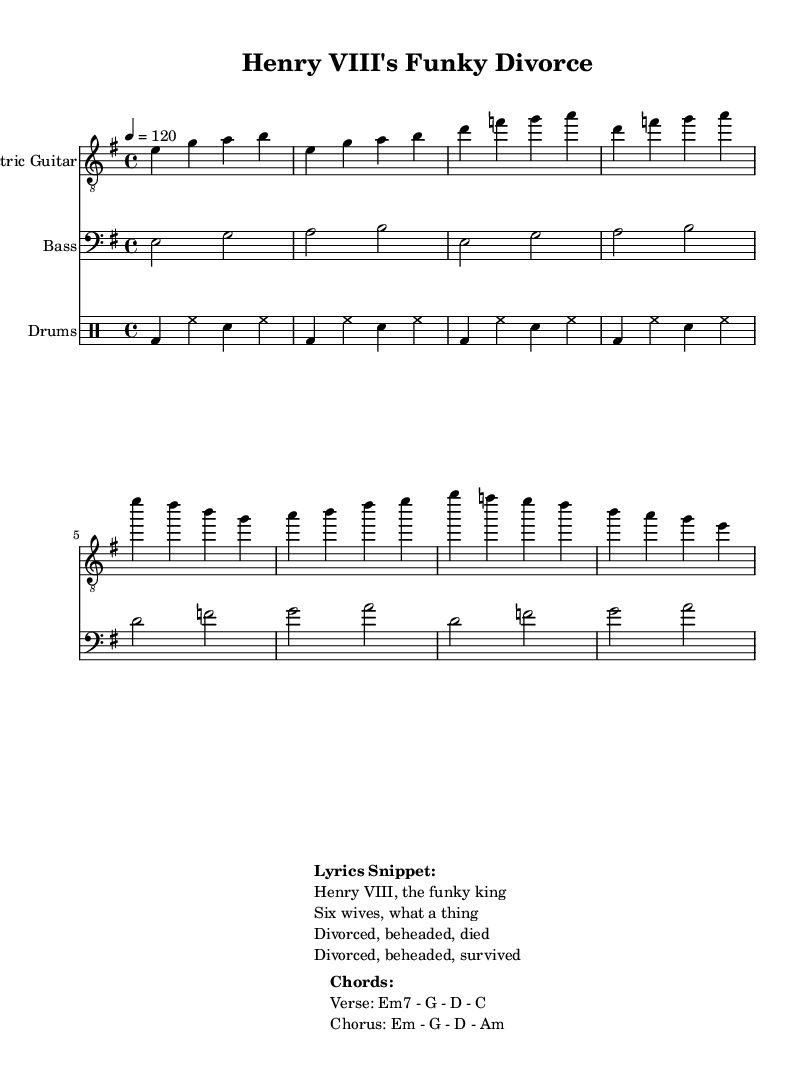What is the key signature of this music? The key signature is indicated by the presence of a single sharp, which denotes E minor.
Answer: E minor What is the time signature of this music? The time signature is represented by the numbers at the beginning of the sheet music, which shows a 4 on top of a 4, indicating that there are four beats in each measure.
Answer: 4/4 What is the tempo of the music? The tempo is indicated by a marking that specifies a speed of quarter note equals 120 beats per minute.
Answer: 120 What is the primary instrument shown in this sheet music? The sheet includes a staff explicitly labeled "Electric Guitar," indicating that it is the primary instrument featured.
Answer: Electric Guitar What main chord progression is used in the verse? The chord symbols listed under "Chords" section show that the verse uses a progression of Em7, G, D, C, indicating the main harmonic structure.
Answer: Em7 - G - D - C How many measures does the drum part consist of? The drum part is notated and contains four measures, each represented by a set of four beats which repeats in the same rhythm, confirming the total count of measures.
Answer: 4 What lyrical theme does this song focus on? The lyrics presented in the "Lyrics Snippet" section clearly relate to the life and legacies of Henry VIII, emphasizing his marital history and outcomes.
Answer: Henry VIII's marriages 